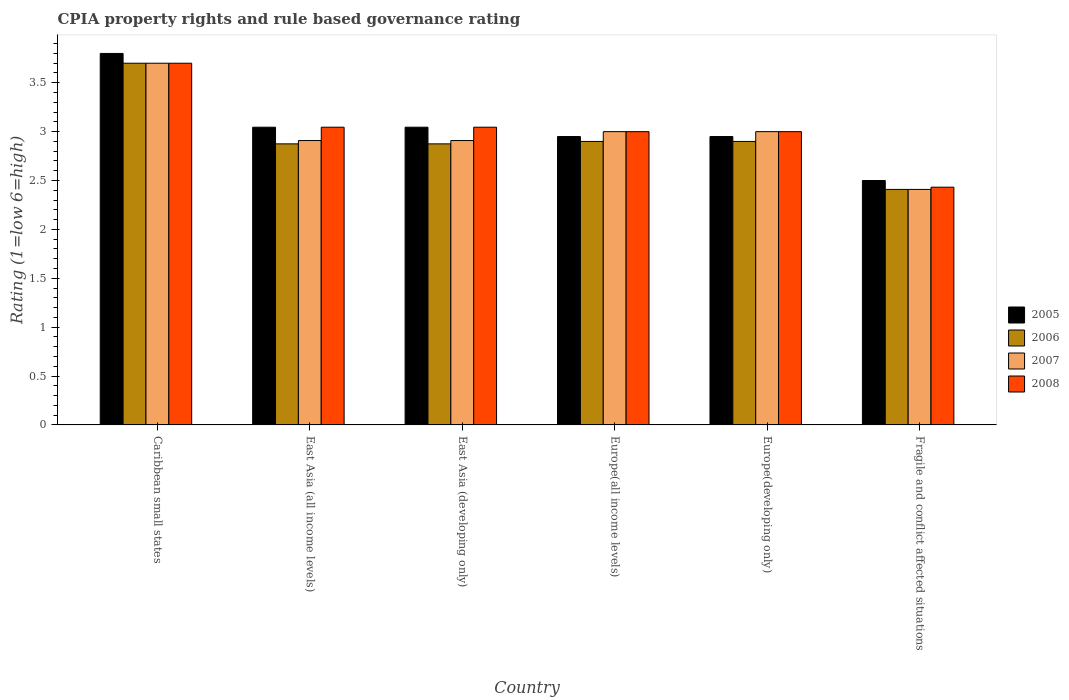How many groups of bars are there?
Your answer should be compact. 6. Are the number of bars per tick equal to the number of legend labels?
Make the answer very short. Yes. Are the number of bars on each tick of the X-axis equal?
Give a very brief answer. Yes. How many bars are there on the 5th tick from the left?
Give a very brief answer. 4. What is the label of the 6th group of bars from the left?
Your answer should be compact. Fragile and conflict affected situations. In how many cases, is the number of bars for a given country not equal to the number of legend labels?
Provide a succinct answer. 0. What is the CPIA rating in 2005 in East Asia (all income levels)?
Offer a very short reply. 3.05. Across all countries, what is the maximum CPIA rating in 2008?
Make the answer very short. 3.7. Across all countries, what is the minimum CPIA rating in 2006?
Give a very brief answer. 2.41. In which country was the CPIA rating in 2006 maximum?
Offer a very short reply. Caribbean small states. In which country was the CPIA rating in 2007 minimum?
Your answer should be very brief. Fragile and conflict affected situations. What is the total CPIA rating in 2008 in the graph?
Give a very brief answer. 18.22. What is the difference between the CPIA rating in 2007 in Europe(developing only) and that in Fragile and conflict affected situations?
Your response must be concise. 0.59. What is the difference between the CPIA rating in 2005 in Fragile and conflict affected situations and the CPIA rating in 2007 in Caribbean small states?
Offer a very short reply. -1.2. What is the average CPIA rating in 2005 per country?
Make the answer very short. 3.05. What is the difference between the CPIA rating of/in 2006 and CPIA rating of/in 2008 in Fragile and conflict affected situations?
Make the answer very short. -0.02. In how many countries, is the CPIA rating in 2008 greater than 1.7?
Your answer should be very brief. 6. What is the ratio of the CPIA rating in 2005 in East Asia (all income levels) to that in Fragile and conflict affected situations?
Keep it short and to the point. 1.22. What is the difference between the highest and the second highest CPIA rating in 2006?
Make the answer very short. -0.8. What is the difference between the highest and the lowest CPIA rating in 2008?
Your answer should be very brief. 1.27. Is the sum of the CPIA rating in 2008 in Caribbean small states and Europe(developing only) greater than the maximum CPIA rating in 2007 across all countries?
Keep it short and to the point. Yes. Is it the case that in every country, the sum of the CPIA rating in 2006 and CPIA rating in 2007 is greater than the sum of CPIA rating in 2008 and CPIA rating in 2005?
Your answer should be very brief. No. How many countries are there in the graph?
Your answer should be very brief. 6. Does the graph contain any zero values?
Offer a terse response. No. Does the graph contain grids?
Make the answer very short. No. Where does the legend appear in the graph?
Offer a terse response. Center right. What is the title of the graph?
Provide a succinct answer. CPIA property rights and rule based governance rating. Does "1997" appear as one of the legend labels in the graph?
Your answer should be compact. No. What is the Rating (1=low 6=high) of 2005 in Caribbean small states?
Offer a very short reply. 3.8. What is the Rating (1=low 6=high) of 2005 in East Asia (all income levels)?
Provide a succinct answer. 3.05. What is the Rating (1=low 6=high) of 2006 in East Asia (all income levels)?
Your response must be concise. 2.88. What is the Rating (1=low 6=high) of 2007 in East Asia (all income levels)?
Offer a terse response. 2.91. What is the Rating (1=low 6=high) of 2008 in East Asia (all income levels)?
Ensure brevity in your answer.  3.05. What is the Rating (1=low 6=high) of 2005 in East Asia (developing only)?
Offer a terse response. 3.05. What is the Rating (1=low 6=high) in 2006 in East Asia (developing only)?
Make the answer very short. 2.88. What is the Rating (1=low 6=high) in 2007 in East Asia (developing only)?
Provide a short and direct response. 2.91. What is the Rating (1=low 6=high) in 2008 in East Asia (developing only)?
Give a very brief answer. 3.05. What is the Rating (1=low 6=high) in 2005 in Europe(all income levels)?
Your answer should be compact. 2.95. What is the Rating (1=low 6=high) in 2006 in Europe(all income levels)?
Keep it short and to the point. 2.9. What is the Rating (1=low 6=high) in 2007 in Europe(all income levels)?
Give a very brief answer. 3. What is the Rating (1=low 6=high) in 2005 in Europe(developing only)?
Provide a short and direct response. 2.95. What is the Rating (1=low 6=high) of 2006 in Europe(developing only)?
Provide a succinct answer. 2.9. What is the Rating (1=low 6=high) in 2007 in Europe(developing only)?
Keep it short and to the point. 3. What is the Rating (1=low 6=high) of 2005 in Fragile and conflict affected situations?
Offer a very short reply. 2.5. What is the Rating (1=low 6=high) of 2006 in Fragile and conflict affected situations?
Provide a succinct answer. 2.41. What is the Rating (1=low 6=high) in 2007 in Fragile and conflict affected situations?
Provide a short and direct response. 2.41. What is the Rating (1=low 6=high) in 2008 in Fragile and conflict affected situations?
Offer a very short reply. 2.43. Across all countries, what is the maximum Rating (1=low 6=high) in 2006?
Ensure brevity in your answer.  3.7. Across all countries, what is the minimum Rating (1=low 6=high) of 2005?
Give a very brief answer. 2.5. Across all countries, what is the minimum Rating (1=low 6=high) in 2006?
Provide a succinct answer. 2.41. Across all countries, what is the minimum Rating (1=low 6=high) in 2007?
Ensure brevity in your answer.  2.41. Across all countries, what is the minimum Rating (1=low 6=high) in 2008?
Offer a very short reply. 2.43. What is the total Rating (1=low 6=high) of 2005 in the graph?
Make the answer very short. 18.29. What is the total Rating (1=low 6=high) of 2006 in the graph?
Offer a very short reply. 17.66. What is the total Rating (1=low 6=high) of 2007 in the graph?
Your response must be concise. 17.93. What is the total Rating (1=low 6=high) of 2008 in the graph?
Your answer should be compact. 18.22. What is the difference between the Rating (1=low 6=high) in 2005 in Caribbean small states and that in East Asia (all income levels)?
Give a very brief answer. 0.75. What is the difference between the Rating (1=low 6=high) of 2006 in Caribbean small states and that in East Asia (all income levels)?
Your response must be concise. 0.82. What is the difference between the Rating (1=low 6=high) in 2007 in Caribbean small states and that in East Asia (all income levels)?
Give a very brief answer. 0.79. What is the difference between the Rating (1=low 6=high) of 2008 in Caribbean small states and that in East Asia (all income levels)?
Offer a terse response. 0.65. What is the difference between the Rating (1=low 6=high) in 2005 in Caribbean small states and that in East Asia (developing only)?
Your answer should be very brief. 0.75. What is the difference between the Rating (1=low 6=high) of 2006 in Caribbean small states and that in East Asia (developing only)?
Offer a terse response. 0.82. What is the difference between the Rating (1=low 6=high) of 2007 in Caribbean small states and that in East Asia (developing only)?
Keep it short and to the point. 0.79. What is the difference between the Rating (1=low 6=high) in 2008 in Caribbean small states and that in East Asia (developing only)?
Your answer should be compact. 0.65. What is the difference between the Rating (1=low 6=high) in 2005 in Caribbean small states and that in Europe(all income levels)?
Offer a very short reply. 0.85. What is the difference between the Rating (1=low 6=high) in 2006 in Caribbean small states and that in Europe(all income levels)?
Your answer should be compact. 0.8. What is the difference between the Rating (1=low 6=high) in 2007 in Caribbean small states and that in Europe(all income levels)?
Give a very brief answer. 0.7. What is the difference between the Rating (1=low 6=high) in 2008 in Caribbean small states and that in Europe(all income levels)?
Offer a very short reply. 0.7. What is the difference between the Rating (1=low 6=high) in 2006 in Caribbean small states and that in Europe(developing only)?
Offer a very short reply. 0.8. What is the difference between the Rating (1=low 6=high) of 2007 in Caribbean small states and that in Europe(developing only)?
Provide a short and direct response. 0.7. What is the difference between the Rating (1=low 6=high) of 2006 in Caribbean small states and that in Fragile and conflict affected situations?
Your answer should be compact. 1.29. What is the difference between the Rating (1=low 6=high) in 2007 in Caribbean small states and that in Fragile and conflict affected situations?
Give a very brief answer. 1.29. What is the difference between the Rating (1=low 6=high) of 2008 in Caribbean small states and that in Fragile and conflict affected situations?
Your answer should be very brief. 1.27. What is the difference between the Rating (1=low 6=high) in 2005 in East Asia (all income levels) and that in Europe(all income levels)?
Give a very brief answer. 0.1. What is the difference between the Rating (1=low 6=high) of 2006 in East Asia (all income levels) and that in Europe(all income levels)?
Give a very brief answer. -0.03. What is the difference between the Rating (1=low 6=high) in 2007 in East Asia (all income levels) and that in Europe(all income levels)?
Provide a succinct answer. -0.09. What is the difference between the Rating (1=low 6=high) of 2008 in East Asia (all income levels) and that in Europe(all income levels)?
Give a very brief answer. 0.05. What is the difference between the Rating (1=low 6=high) in 2005 in East Asia (all income levels) and that in Europe(developing only)?
Keep it short and to the point. 0.1. What is the difference between the Rating (1=low 6=high) of 2006 in East Asia (all income levels) and that in Europe(developing only)?
Provide a short and direct response. -0.03. What is the difference between the Rating (1=low 6=high) of 2007 in East Asia (all income levels) and that in Europe(developing only)?
Offer a very short reply. -0.09. What is the difference between the Rating (1=low 6=high) in 2008 in East Asia (all income levels) and that in Europe(developing only)?
Your answer should be compact. 0.05. What is the difference between the Rating (1=low 6=high) in 2005 in East Asia (all income levels) and that in Fragile and conflict affected situations?
Provide a short and direct response. 0.55. What is the difference between the Rating (1=low 6=high) of 2006 in East Asia (all income levels) and that in Fragile and conflict affected situations?
Provide a succinct answer. 0.47. What is the difference between the Rating (1=low 6=high) in 2007 in East Asia (all income levels) and that in Fragile and conflict affected situations?
Give a very brief answer. 0.5. What is the difference between the Rating (1=low 6=high) in 2008 in East Asia (all income levels) and that in Fragile and conflict affected situations?
Provide a succinct answer. 0.61. What is the difference between the Rating (1=low 6=high) of 2005 in East Asia (developing only) and that in Europe(all income levels)?
Ensure brevity in your answer.  0.1. What is the difference between the Rating (1=low 6=high) in 2006 in East Asia (developing only) and that in Europe(all income levels)?
Provide a short and direct response. -0.03. What is the difference between the Rating (1=low 6=high) of 2007 in East Asia (developing only) and that in Europe(all income levels)?
Offer a very short reply. -0.09. What is the difference between the Rating (1=low 6=high) of 2008 in East Asia (developing only) and that in Europe(all income levels)?
Your answer should be compact. 0.05. What is the difference between the Rating (1=low 6=high) of 2005 in East Asia (developing only) and that in Europe(developing only)?
Ensure brevity in your answer.  0.1. What is the difference between the Rating (1=low 6=high) in 2006 in East Asia (developing only) and that in Europe(developing only)?
Keep it short and to the point. -0.03. What is the difference between the Rating (1=low 6=high) of 2007 in East Asia (developing only) and that in Europe(developing only)?
Ensure brevity in your answer.  -0.09. What is the difference between the Rating (1=low 6=high) in 2008 in East Asia (developing only) and that in Europe(developing only)?
Provide a succinct answer. 0.05. What is the difference between the Rating (1=low 6=high) of 2005 in East Asia (developing only) and that in Fragile and conflict affected situations?
Offer a terse response. 0.55. What is the difference between the Rating (1=low 6=high) of 2006 in East Asia (developing only) and that in Fragile and conflict affected situations?
Provide a succinct answer. 0.47. What is the difference between the Rating (1=low 6=high) in 2007 in East Asia (developing only) and that in Fragile and conflict affected situations?
Offer a very short reply. 0.5. What is the difference between the Rating (1=low 6=high) of 2008 in East Asia (developing only) and that in Fragile and conflict affected situations?
Ensure brevity in your answer.  0.61. What is the difference between the Rating (1=low 6=high) of 2005 in Europe(all income levels) and that in Europe(developing only)?
Offer a terse response. 0. What is the difference between the Rating (1=low 6=high) in 2006 in Europe(all income levels) and that in Europe(developing only)?
Keep it short and to the point. 0. What is the difference between the Rating (1=low 6=high) of 2008 in Europe(all income levels) and that in Europe(developing only)?
Your response must be concise. 0. What is the difference between the Rating (1=low 6=high) of 2005 in Europe(all income levels) and that in Fragile and conflict affected situations?
Your answer should be very brief. 0.45. What is the difference between the Rating (1=low 6=high) in 2006 in Europe(all income levels) and that in Fragile and conflict affected situations?
Your response must be concise. 0.49. What is the difference between the Rating (1=low 6=high) in 2007 in Europe(all income levels) and that in Fragile and conflict affected situations?
Offer a terse response. 0.59. What is the difference between the Rating (1=low 6=high) of 2008 in Europe(all income levels) and that in Fragile and conflict affected situations?
Provide a short and direct response. 0.57. What is the difference between the Rating (1=low 6=high) of 2005 in Europe(developing only) and that in Fragile and conflict affected situations?
Give a very brief answer. 0.45. What is the difference between the Rating (1=low 6=high) in 2006 in Europe(developing only) and that in Fragile and conflict affected situations?
Provide a succinct answer. 0.49. What is the difference between the Rating (1=low 6=high) in 2007 in Europe(developing only) and that in Fragile and conflict affected situations?
Provide a succinct answer. 0.59. What is the difference between the Rating (1=low 6=high) in 2008 in Europe(developing only) and that in Fragile and conflict affected situations?
Ensure brevity in your answer.  0.57. What is the difference between the Rating (1=low 6=high) in 2005 in Caribbean small states and the Rating (1=low 6=high) in 2006 in East Asia (all income levels)?
Offer a very short reply. 0.93. What is the difference between the Rating (1=low 6=high) in 2005 in Caribbean small states and the Rating (1=low 6=high) in 2007 in East Asia (all income levels)?
Offer a very short reply. 0.89. What is the difference between the Rating (1=low 6=high) in 2005 in Caribbean small states and the Rating (1=low 6=high) in 2008 in East Asia (all income levels)?
Offer a terse response. 0.75. What is the difference between the Rating (1=low 6=high) in 2006 in Caribbean small states and the Rating (1=low 6=high) in 2007 in East Asia (all income levels)?
Give a very brief answer. 0.79. What is the difference between the Rating (1=low 6=high) in 2006 in Caribbean small states and the Rating (1=low 6=high) in 2008 in East Asia (all income levels)?
Give a very brief answer. 0.65. What is the difference between the Rating (1=low 6=high) in 2007 in Caribbean small states and the Rating (1=low 6=high) in 2008 in East Asia (all income levels)?
Ensure brevity in your answer.  0.65. What is the difference between the Rating (1=low 6=high) of 2005 in Caribbean small states and the Rating (1=low 6=high) of 2006 in East Asia (developing only)?
Ensure brevity in your answer.  0.93. What is the difference between the Rating (1=low 6=high) of 2005 in Caribbean small states and the Rating (1=low 6=high) of 2007 in East Asia (developing only)?
Give a very brief answer. 0.89. What is the difference between the Rating (1=low 6=high) of 2005 in Caribbean small states and the Rating (1=low 6=high) of 2008 in East Asia (developing only)?
Your response must be concise. 0.75. What is the difference between the Rating (1=low 6=high) in 2006 in Caribbean small states and the Rating (1=low 6=high) in 2007 in East Asia (developing only)?
Provide a short and direct response. 0.79. What is the difference between the Rating (1=low 6=high) in 2006 in Caribbean small states and the Rating (1=low 6=high) in 2008 in East Asia (developing only)?
Your answer should be very brief. 0.65. What is the difference between the Rating (1=low 6=high) of 2007 in Caribbean small states and the Rating (1=low 6=high) of 2008 in East Asia (developing only)?
Provide a succinct answer. 0.65. What is the difference between the Rating (1=low 6=high) of 2006 in Caribbean small states and the Rating (1=low 6=high) of 2007 in Europe(all income levels)?
Make the answer very short. 0.7. What is the difference between the Rating (1=low 6=high) of 2007 in Caribbean small states and the Rating (1=low 6=high) of 2008 in Europe(all income levels)?
Your answer should be compact. 0.7. What is the difference between the Rating (1=low 6=high) of 2005 in Caribbean small states and the Rating (1=low 6=high) of 2006 in Europe(developing only)?
Your answer should be very brief. 0.9. What is the difference between the Rating (1=low 6=high) in 2006 in Caribbean small states and the Rating (1=low 6=high) in 2007 in Europe(developing only)?
Give a very brief answer. 0.7. What is the difference between the Rating (1=low 6=high) of 2005 in Caribbean small states and the Rating (1=low 6=high) of 2006 in Fragile and conflict affected situations?
Provide a succinct answer. 1.39. What is the difference between the Rating (1=low 6=high) of 2005 in Caribbean small states and the Rating (1=low 6=high) of 2007 in Fragile and conflict affected situations?
Your answer should be very brief. 1.39. What is the difference between the Rating (1=low 6=high) of 2005 in Caribbean small states and the Rating (1=low 6=high) of 2008 in Fragile and conflict affected situations?
Keep it short and to the point. 1.37. What is the difference between the Rating (1=low 6=high) of 2006 in Caribbean small states and the Rating (1=low 6=high) of 2007 in Fragile and conflict affected situations?
Offer a very short reply. 1.29. What is the difference between the Rating (1=low 6=high) in 2006 in Caribbean small states and the Rating (1=low 6=high) in 2008 in Fragile and conflict affected situations?
Provide a short and direct response. 1.27. What is the difference between the Rating (1=low 6=high) of 2007 in Caribbean small states and the Rating (1=low 6=high) of 2008 in Fragile and conflict affected situations?
Offer a terse response. 1.27. What is the difference between the Rating (1=low 6=high) in 2005 in East Asia (all income levels) and the Rating (1=low 6=high) in 2006 in East Asia (developing only)?
Provide a succinct answer. 0.17. What is the difference between the Rating (1=low 6=high) in 2005 in East Asia (all income levels) and the Rating (1=low 6=high) in 2007 in East Asia (developing only)?
Offer a very short reply. 0.14. What is the difference between the Rating (1=low 6=high) of 2006 in East Asia (all income levels) and the Rating (1=low 6=high) of 2007 in East Asia (developing only)?
Your answer should be very brief. -0.03. What is the difference between the Rating (1=low 6=high) in 2006 in East Asia (all income levels) and the Rating (1=low 6=high) in 2008 in East Asia (developing only)?
Your answer should be compact. -0.17. What is the difference between the Rating (1=low 6=high) in 2007 in East Asia (all income levels) and the Rating (1=low 6=high) in 2008 in East Asia (developing only)?
Give a very brief answer. -0.14. What is the difference between the Rating (1=low 6=high) in 2005 in East Asia (all income levels) and the Rating (1=low 6=high) in 2006 in Europe(all income levels)?
Offer a terse response. 0.15. What is the difference between the Rating (1=low 6=high) in 2005 in East Asia (all income levels) and the Rating (1=low 6=high) in 2007 in Europe(all income levels)?
Keep it short and to the point. 0.05. What is the difference between the Rating (1=low 6=high) of 2005 in East Asia (all income levels) and the Rating (1=low 6=high) of 2008 in Europe(all income levels)?
Your response must be concise. 0.05. What is the difference between the Rating (1=low 6=high) of 2006 in East Asia (all income levels) and the Rating (1=low 6=high) of 2007 in Europe(all income levels)?
Offer a terse response. -0.12. What is the difference between the Rating (1=low 6=high) of 2006 in East Asia (all income levels) and the Rating (1=low 6=high) of 2008 in Europe(all income levels)?
Provide a succinct answer. -0.12. What is the difference between the Rating (1=low 6=high) in 2007 in East Asia (all income levels) and the Rating (1=low 6=high) in 2008 in Europe(all income levels)?
Provide a short and direct response. -0.09. What is the difference between the Rating (1=low 6=high) in 2005 in East Asia (all income levels) and the Rating (1=low 6=high) in 2006 in Europe(developing only)?
Provide a short and direct response. 0.15. What is the difference between the Rating (1=low 6=high) of 2005 in East Asia (all income levels) and the Rating (1=low 6=high) of 2007 in Europe(developing only)?
Provide a short and direct response. 0.05. What is the difference between the Rating (1=low 6=high) of 2005 in East Asia (all income levels) and the Rating (1=low 6=high) of 2008 in Europe(developing only)?
Offer a terse response. 0.05. What is the difference between the Rating (1=low 6=high) of 2006 in East Asia (all income levels) and the Rating (1=low 6=high) of 2007 in Europe(developing only)?
Provide a succinct answer. -0.12. What is the difference between the Rating (1=low 6=high) in 2006 in East Asia (all income levels) and the Rating (1=low 6=high) in 2008 in Europe(developing only)?
Provide a succinct answer. -0.12. What is the difference between the Rating (1=low 6=high) in 2007 in East Asia (all income levels) and the Rating (1=low 6=high) in 2008 in Europe(developing only)?
Give a very brief answer. -0.09. What is the difference between the Rating (1=low 6=high) in 2005 in East Asia (all income levels) and the Rating (1=low 6=high) in 2006 in Fragile and conflict affected situations?
Keep it short and to the point. 0.64. What is the difference between the Rating (1=low 6=high) of 2005 in East Asia (all income levels) and the Rating (1=low 6=high) of 2007 in Fragile and conflict affected situations?
Offer a terse response. 0.64. What is the difference between the Rating (1=low 6=high) in 2005 in East Asia (all income levels) and the Rating (1=low 6=high) in 2008 in Fragile and conflict affected situations?
Offer a terse response. 0.61. What is the difference between the Rating (1=low 6=high) of 2006 in East Asia (all income levels) and the Rating (1=low 6=high) of 2007 in Fragile and conflict affected situations?
Provide a short and direct response. 0.47. What is the difference between the Rating (1=low 6=high) of 2006 in East Asia (all income levels) and the Rating (1=low 6=high) of 2008 in Fragile and conflict affected situations?
Your response must be concise. 0.44. What is the difference between the Rating (1=low 6=high) in 2007 in East Asia (all income levels) and the Rating (1=low 6=high) in 2008 in Fragile and conflict affected situations?
Make the answer very short. 0.48. What is the difference between the Rating (1=low 6=high) of 2005 in East Asia (developing only) and the Rating (1=low 6=high) of 2006 in Europe(all income levels)?
Your answer should be very brief. 0.15. What is the difference between the Rating (1=low 6=high) in 2005 in East Asia (developing only) and the Rating (1=low 6=high) in 2007 in Europe(all income levels)?
Provide a succinct answer. 0.05. What is the difference between the Rating (1=low 6=high) in 2005 in East Asia (developing only) and the Rating (1=low 6=high) in 2008 in Europe(all income levels)?
Your answer should be compact. 0.05. What is the difference between the Rating (1=low 6=high) of 2006 in East Asia (developing only) and the Rating (1=low 6=high) of 2007 in Europe(all income levels)?
Your response must be concise. -0.12. What is the difference between the Rating (1=low 6=high) of 2006 in East Asia (developing only) and the Rating (1=low 6=high) of 2008 in Europe(all income levels)?
Give a very brief answer. -0.12. What is the difference between the Rating (1=low 6=high) in 2007 in East Asia (developing only) and the Rating (1=low 6=high) in 2008 in Europe(all income levels)?
Ensure brevity in your answer.  -0.09. What is the difference between the Rating (1=low 6=high) of 2005 in East Asia (developing only) and the Rating (1=low 6=high) of 2006 in Europe(developing only)?
Your response must be concise. 0.15. What is the difference between the Rating (1=low 6=high) of 2005 in East Asia (developing only) and the Rating (1=low 6=high) of 2007 in Europe(developing only)?
Your response must be concise. 0.05. What is the difference between the Rating (1=low 6=high) of 2005 in East Asia (developing only) and the Rating (1=low 6=high) of 2008 in Europe(developing only)?
Offer a terse response. 0.05. What is the difference between the Rating (1=low 6=high) in 2006 in East Asia (developing only) and the Rating (1=low 6=high) in 2007 in Europe(developing only)?
Make the answer very short. -0.12. What is the difference between the Rating (1=low 6=high) of 2006 in East Asia (developing only) and the Rating (1=low 6=high) of 2008 in Europe(developing only)?
Provide a short and direct response. -0.12. What is the difference between the Rating (1=low 6=high) of 2007 in East Asia (developing only) and the Rating (1=low 6=high) of 2008 in Europe(developing only)?
Ensure brevity in your answer.  -0.09. What is the difference between the Rating (1=low 6=high) of 2005 in East Asia (developing only) and the Rating (1=low 6=high) of 2006 in Fragile and conflict affected situations?
Provide a succinct answer. 0.64. What is the difference between the Rating (1=low 6=high) of 2005 in East Asia (developing only) and the Rating (1=low 6=high) of 2007 in Fragile and conflict affected situations?
Make the answer very short. 0.64. What is the difference between the Rating (1=low 6=high) in 2005 in East Asia (developing only) and the Rating (1=low 6=high) in 2008 in Fragile and conflict affected situations?
Offer a very short reply. 0.61. What is the difference between the Rating (1=low 6=high) in 2006 in East Asia (developing only) and the Rating (1=low 6=high) in 2007 in Fragile and conflict affected situations?
Provide a succinct answer. 0.47. What is the difference between the Rating (1=low 6=high) in 2006 in East Asia (developing only) and the Rating (1=low 6=high) in 2008 in Fragile and conflict affected situations?
Ensure brevity in your answer.  0.44. What is the difference between the Rating (1=low 6=high) of 2007 in East Asia (developing only) and the Rating (1=low 6=high) of 2008 in Fragile and conflict affected situations?
Your answer should be compact. 0.48. What is the difference between the Rating (1=low 6=high) of 2005 in Europe(all income levels) and the Rating (1=low 6=high) of 2007 in Europe(developing only)?
Provide a succinct answer. -0.05. What is the difference between the Rating (1=low 6=high) of 2005 in Europe(all income levels) and the Rating (1=low 6=high) of 2008 in Europe(developing only)?
Provide a short and direct response. -0.05. What is the difference between the Rating (1=low 6=high) in 2006 in Europe(all income levels) and the Rating (1=low 6=high) in 2008 in Europe(developing only)?
Offer a very short reply. -0.1. What is the difference between the Rating (1=low 6=high) of 2007 in Europe(all income levels) and the Rating (1=low 6=high) of 2008 in Europe(developing only)?
Your answer should be very brief. 0. What is the difference between the Rating (1=low 6=high) in 2005 in Europe(all income levels) and the Rating (1=low 6=high) in 2006 in Fragile and conflict affected situations?
Provide a succinct answer. 0.54. What is the difference between the Rating (1=low 6=high) in 2005 in Europe(all income levels) and the Rating (1=low 6=high) in 2007 in Fragile and conflict affected situations?
Give a very brief answer. 0.54. What is the difference between the Rating (1=low 6=high) of 2005 in Europe(all income levels) and the Rating (1=low 6=high) of 2008 in Fragile and conflict affected situations?
Offer a terse response. 0.52. What is the difference between the Rating (1=low 6=high) of 2006 in Europe(all income levels) and the Rating (1=low 6=high) of 2007 in Fragile and conflict affected situations?
Offer a very short reply. 0.49. What is the difference between the Rating (1=low 6=high) of 2006 in Europe(all income levels) and the Rating (1=low 6=high) of 2008 in Fragile and conflict affected situations?
Provide a short and direct response. 0.47. What is the difference between the Rating (1=low 6=high) of 2007 in Europe(all income levels) and the Rating (1=low 6=high) of 2008 in Fragile and conflict affected situations?
Provide a succinct answer. 0.57. What is the difference between the Rating (1=low 6=high) in 2005 in Europe(developing only) and the Rating (1=low 6=high) in 2006 in Fragile and conflict affected situations?
Give a very brief answer. 0.54. What is the difference between the Rating (1=low 6=high) of 2005 in Europe(developing only) and the Rating (1=low 6=high) of 2007 in Fragile and conflict affected situations?
Your response must be concise. 0.54. What is the difference between the Rating (1=low 6=high) of 2005 in Europe(developing only) and the Rating (1=low 6=high) of 2008 in Fragile and conflict affected situations?
Provide a short and direct response. 0.52. What is the difference between the Rating (1=low 6=high) in 2006 in Europe(developing only) and the Rating (1=low 6=high) in 2007 in Fragile and conflict affected situations?
Give a very brief answer. 0.49. What is the difference between the Rating (1=low 6=high) in 2006 in Europe(developing only) and the Rating (1=low 6=high) in 2008 in Fragile and conflict affected situations?
Offer a very short reply. 0.47. What is the difference between the Rating (1=low 6=high) of 2007 in Europe(developing only) and the Rating (1=low 6=high) of 2008 in Fragile and conflict affected situations?
Your answer should be compact. 0.57. What is the average Rating (1=low 6=high) in 2005 per country?
Keep it short and to the point. 3.05. What is the average Rating (1=low 6=high) in 2006 per country?
Offer a terse response. 2.94. What is the average Rating (1=low 6=high) of 2007 per country?
Make the answer very short. 2.99. What is the average Rating (1=low 6=high) in 2008 per country?
Give a very brief answer. 3.04. What is the difference between the Rating (1=low 6=high) of 2005 and Rating (1=low 6=high) of 2006 in Caribbean small states?
Your answer should be compact. 0.1. What is the difference between the Rating (1=low 6=high) of 2005 and Rating (1=low 6=high) of 2008 in Caribbean small states?
Your answer should be compact. 0.1. What is the difference between the Rating (1=low 6=high) of 2006 and Rating (1=low 6=high) of 2007 in Caribbean small states?
Keep it short and to the point. 0. What is the difference between the Rating (1=low 6=high) of 2006 and Rating (1=low 6=high) of 2008 in Caribbean small states?
Offer a very short reply. 0. What is the difference between the Rating (1=low 6=high) in 2005 and Rating (1=low 6=high) in 2006 in East Asia (all income levels)?
Provide a succinct answer. 0.17. What is the difference between the Rating (1=low 6=high) of 2005 and Rating (1=low 6=high) of 2007 in East Asia (all income levels)?
Provide a succinct answer. 0.14. What is the difference between the Rating (1=low 6=high) in 2006 and Rating (1=low 6=high) in 2007 in East Asia (all income levels)?
Make the answer very short. -0.03. What is the difference between the Rating (1=low 6=high) of 2006 and Rating (1=low 6=high) of 2008 in East Asia (all income levels)?
Your answer should be compact. -0.17. What is the difference between the Rating (1=low 6=high) in 2007 and Rating (1=low 6=high) in 2008 in East Asia (all income levels)?
Your response must be concise. -0.14. What is the difference between the Rating (1=low 6=high) of 2005 and Rating (1=low 6=high) of 2006 in East Asia (developing only)?
Your answer should be compact. 0.17. What is the difference between the Rating (1=low 6=high) in 2005 and Rating (1=low 6=high) in 2007 in East Asia (developing only)?
Offer a terse response. 0.14. What is the difference between the Rating (1=low 6=high) in 2006 and Rating (1=low 6=high) in 2007 in East Asia (developing only)?
Make the answer very short. -0.03. What is the difference between the Rating (1=low 6=high) of 2006 and Rating (1=low 6=high) of 2008 in East Asia (developing only)?
Offer a very short reply. -0.17. What is the difference between the Rating (1=low 6=high) of 2007 and Rating (1=low 6=high) of 2008 in East Asia (developing only)?
Your answer should be compact. -0.14. What is the difference between the Rating (1=low 6=high) in 2005 and Rating (1=low 6=high) in 2007 in Europe(all income levels)?
Offer a terse response. -0.05. What is the difference between the Rating (1=low 6=high) in 2005 and Rating (1=low 6=high) in 2008 in Europe(all income levels)?
Your answer should be very brief. -0.05. What is the difference between the Rating (1=low 6=high) of 2006 and Rating (1=low 6=high) of 2007 in Europe(all income levels)?
Provide a succinct answer. -0.1. What is the difference between the Rating (1=low 6=high) of 2007 and Rating (1=low 6=high) of 2008 in Europe(all income levels)?
Your response must be concise. 0. What is the difference between the Rating (1=low 6=high) of 2005 and Rating (1=low 6=high) of 2006 in Europe(developing only)?
Your answer should be compact. 0.05. What is the difference between the Rating (1=low 6=high) in 2005 and Rating (1=low 6=high) in 2007 in Europe(developing only)?
Make the answer very short. -0.05. What is the difference between the Rating (1=low 6=high) in 2006 and Rating (1=low 6=high) in 2008 in Europe(developing only)?
Keep it short and to the point. -0.1. What is the difference between the Rating (1=low 6=high) of 2005 and Rating (1=low 6=high) of 2006 in Fragile and conflict affected situations?
Keep it short and to the point. 0.09. What is the difference between the Rating (1=low 6=high) of 2005 and Rating (1=low 6=high) of 2007 in Fragile and conflict affected situations?
Your answer should be compact. 0.09. What is the difference between the Rating (1=low 6=high) of 2005 and Rating (1=low 6=high) of 2008 in Fragile and conflict affected situations?
Offer a terse response. 0.07. What is the difference between the Rating (1=low 6=high) of 2006 and Rating (1=low 6=high) of 2008 in Fragile and conflict affected situations?
Your answer should be compact. -0.02. What is the difference between the Rating (1=low 6=high) of 2007 and Rating (1=low 6=high) of 2008 in Fragile and conflict affected situations?
Your response must be concise. -0.02. What is the ratio of the Rating (1=low 6=high) of 2005 in Caribbean small states to that in East Asia (all income levels)?
Your response must be concise. 1.25. What is the ratio of the Rating (1=low 6=high) in 2006 in Caribbean small states to that in East Asia (all income levels)?
Keep it short and to the point. 1.29. What is the ratio of the Rating (1=low 6=high) of 2007 in Caribbean small states to that in East Asia (all income levels)?
Provide a short and direct response. 1.27. What is the ratio of the Rating (1=low 6=high) of 2008 in Caribbean small states to that in East Asia (all income levels)?
Ensure brevity in your answer.  1.21. What is the ratio of the Rating (1=low 6=high) of 2005 in Caribbean small states to that in East Asia (developing only)?
Provide a succinct answer. 1.25. What is the ratio of the Rating (1=low 6=high) of 2006 in Caribbean small states to that in East Asia (developing only)?
Offer a very short reply. 1.29. What is the ratio of the Rating (1=low 6=high) of 2007 in Caribbean small states to that in East Asia (developing only)?
Provide a short and direct response. 1.27. What is the ratio of the Rating (1=low 6=high) in 2008 in Caribbean small states to that in East Asia (developing only)?
Provide a succinct answer. 1.21. What is the ratio of the Rating (1=low 6=high) of 2005 in Caribbean small states to that in Europe(all income levels)?
Your response must be concise. 1.29. What is the ratio of the Rating (1=low 6=high) of 2006 in Caribbean small states to that in Europe(all income levels)?
Keep it short and to the point. 1.28. What is the ratio of the Rating (1=low 6=high) of 2007 in Caribbean small states to that in Europe(all income levels)?
Provide a short and direct response. 1.23. What is the ratio of the Rating (1=low 6=high) of 2008 in Caribbean small states to that in Europe(all income levels)?
Give a very brief answer. 1.23. What is the ratio of the Rating (1=low 6=high) in 2005 in Caribbean small states to that in Europe(developing only)?
Ensure brevity in your answer.  1.29. What is the ratio of the Rating (1=low 6=high) in 2006 in Caribbean small states to that in Europe(developing only)?
Your answer should be compact. 1.28. What is the ratio of the Rating (1=low 6=high) in 2007 in Caribbean small states to that in Europe(developing only)?
Offer a terse response. 1.23. What is the ratio of the Rating (1=low 6=high) in 2008 in Caribbean small states to that in Europe(developing only)?
Provide a succinct answer. 1.23. What is the ratio of the Rating (1=low 6=high) in 2005 in Caribbean small states to that in Fragile and conflict affected situations?
Offer a very short reply. 1.52. What is the ratio of the Rating (1=low 6=high) of 2006 in Caribbean small states to that in Fragile and conflict affected situations?
Your answer should be very brief. 1.54. What is the ratio of the Rating (1=low 6=high) in 2007 in Caribbean small states to that in Fragile and conflict affected situations?
Give a very brief answer. 1.54. What is the ratio of the Rating (1=low 6=high) in 2008 in Caribbean small states to that in Fragile and conflict affected situations?
Provide a short and direct response. 1.52. What is the ratio of the Rating (1=low 6=high) of 2005 in East Asia (all income levels) to that in East Asia (developing only)?
Your response must be concise. 1. What is the ratio of the Rating (1=low 6=high) in 2007 in East Asia (all income levels) to that in East Asia (developing only)?
Ensure brevity in your answer.  1. What is the ratio of the Rating (1=low 6=high) in 2005 in East Asia (all income levels) to that in Europe(all income levels)?
Your response must be concise. 1.03. What is the ratio of the Rating (1=low 6=high) in 2007 in East Asia (all income levels) to that in Europe(all income levels)?
Offer a terse response. 0.97. What is the ratio of the Rating (1=low 6=high) of 2008 in East Asia (all income levels) to that in Europe(all income levels)?
Provide a succinct answer. 1.02. What is the ratio of the Rating (1=low 6=high) of 2005 in East Asia (all income levels) to that in Europe(developing only)?
Your answer should be compact. 1.03. What is the ratio of the Rating (1=low 6=high) in 2006 in East Asia (all income levels) to that in Europe(developing only)?
Provide a succinct answer. 0.99. What is the ratio of the Rating (1=low 6=high) of 2007 in East Asia (all income levels) to that in Europe(developing only)?
Your answer should be compact. 0.97. What is the ratio of the Rating (1=low 6=high) of 2008 in East Asia (all income levels) to that in Europe(developing only)?
Make the answer very short. 1.02. What is the ratio of the Rating (1=low 6=high) in 2005 in East Asia (all income levels) to that in Fragile and conflict affected situations?
Offer a very short reply. 1.22. What is the ratio of the Rating (1=low 6=high) of 2006 in East Asia (all income levels) to that in Fragile and conflict affected situations?
Keep it short and to the point. 1.19. What is the ratio of the Rating (1=low 6=high) in 2007 in East Asia (all income levels) to that in Fragile and conflict affected situations?
Keep it short and to the point. 1.21. What is the ratio of the Rating (1=low 6=high) of 2008 in East Asia (all income levels) to that in Fragile and conflict affected situations?
Your response must be concise. 1.25. What is the ratio of the Rating (1=low 6=high) in 2005 in East Asia (developing only) to that in Europe(all income levels)?
Keep it short and to the point. 1.03. What is the ratio of the Rating (1=low 6=high) of 2006 in East Asia (developing only) to that in Europe(all income levels)?
Keep it short and to the point. 0.99. What is the ratio of the Rating (1=low 6=high) of 2007 in East Asia (developing only) to that in Europe(all income levels)?
Your answer should be very brief. 0.97. What is the ratio of the Rating (1=low 6=high) of 2008 in East Asia (developing only) to that in Europe(all income levels)?
Your answer should be very brief. 1.02. What is the ratio of the Rating (1=low 6=high) in 2005 in East Asia (developing only) to that in Europe(developing only)?
Ensure brevity in your answer.  1.03. What is the ratio of the Rating (1=low 6=high) in 2007 in East Asia (developing only) to that in Europe(developing only)?
Keep it short and to the point. 0.97. What is the ratio of the Rating (1=low 6=high) in 2008 in East Asia (developing only) to that in Europe(developing only)?
Offer a terse response. 1.02. What is the ratio of the Rating (1=low 6=high) of 2005 in East Asia (developing only) to that in Fragile and conflict affected situations?
Keep it short and to the point. 1.22. What is the ratio of the Rating (1=low 6=high) of 2006 in East Asia (developing only) to that in Fragile and conflict affected situations?
Provide a short and direct response. 1.19. What is the ratio of the Rating (1=low 6=high) in 2007 in East Asia (developing only) to that in Fragile and conflict affected situations?
Make the answer very short. 1.21. What is the ratio of the Rating (1=low 6=high) of 2008 in East Asia (developing only) to that in Fragile and conflict affected situations?
Give a very brief answer. 1.25. What is the ratio of the Rating (1=low 6=high) in 2005 in Europe(all income levels) to that in Europe(developing only)?
Your answer should be very brief. 1. What is the ratio of the Rating (1=low 6=high) in 2006 in Europe(all income levels) to that in Europe(developing only)?
Make the answer very short. 1. What is the ratio of the Rating (1=low 6=high) in 2005 in Europe(all income levels) to that in Fragile and conflict affected situations?
Offer a very short reply. 1.18. What is the ratio of the Rating (1=low 6=high) in 2006 in Europe(all income levels) to that in Fragile and conflict affected situations?
Offer a terse response. 1.2. What is the ratio of the Rating (1=low 6=high) in 2007 in Europe(all income levels) to that in Fragile and conflict affected situations?
Make the answer very short. 1.25. What is the ratio of the Rating (1=low 6=high) in 2008 in Europe(all income levels) to that in Fragile and conflict affected situations?
Offer a very short reply. 1.23. What is the ratio of the Rating (1=low 6=high) in 2005 in Europe(developing only) to that in Fragile and conflict affected situations?
Keep it short and to the point. 1.18. What is the ratio of the Rating (1=low 6=high) of 2006 in Europe(developing only) to that in Fragile and conflict affected situations?
Your response must be concise. 1.2. What is the ratio of the Rating (1=low 6=high) in 2007 in Europe(developing only) to that in Fragile and conflict affected situations?
Your answer should be very brief. 1.25. What is the ratio of the Rating (1=low 6=high) in 2008 in Europe(developing only) to that in Fragile and conflict affected situations?
Your answer should be very brief. 1.23. What is the difference between the highest and the second highest Rating (1=low 6=high) in 2005?
Make the answer very short. 0.75. What is the difference between the highest and the second highest Rating (1=low 6=high) of 2007?
Offer a terse response. 0.7. What is the difference between the highest and the second highest Rating (1=low 6=high) in 2008?
Offer a terse response. 0.65. What is the difference between the highest and the lowest Rating (1=low 6=high) in 2005?
Give a very brief answer. 1.3. What is the difference between the highest and the lowest Rating (1=low 6=high) in 2006?
Give a very brief answer. 1.29. What is the difference between the highest and the lowest Rating (1=low 6=high) of 2007?
Make the answer very short. 1.29. What is the difference between the highest and the lowest Rating (1=low 6=high) in 2008?
Provide a short and direct response. 1.27. 